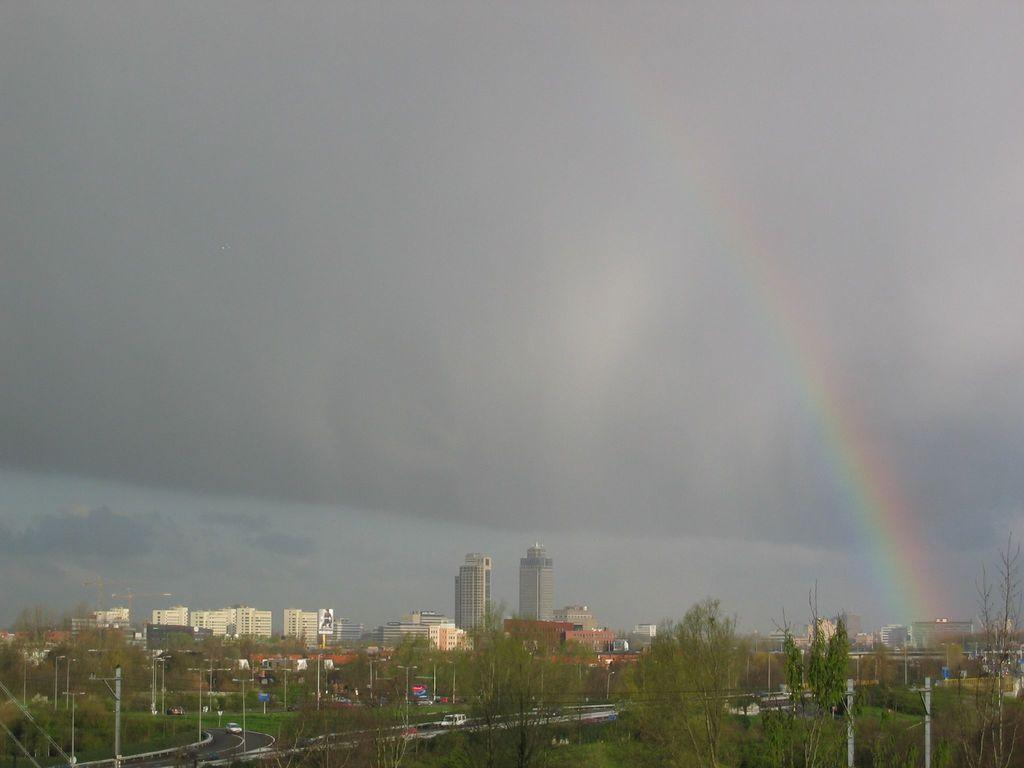What type of natural elements can be seen in the image? There are trees in the image. What type of man-made structures are present in the image? There are buildings in the image. What are the tall, thin objects in the image? There are poles in the image. How would you describe the weather in the image? The sky is cloudy in the image. What colorful phenomenon can be seen in the image? There is a rainbow in the image. What type of transportation is visible in the image? There are vehicles moving on the road in the image. What type of loaf is being pushed by the truck in the image? There is no truck or loaf present in the image. How does the push help the loaf in the image? There is no loaf or push present in the image. 